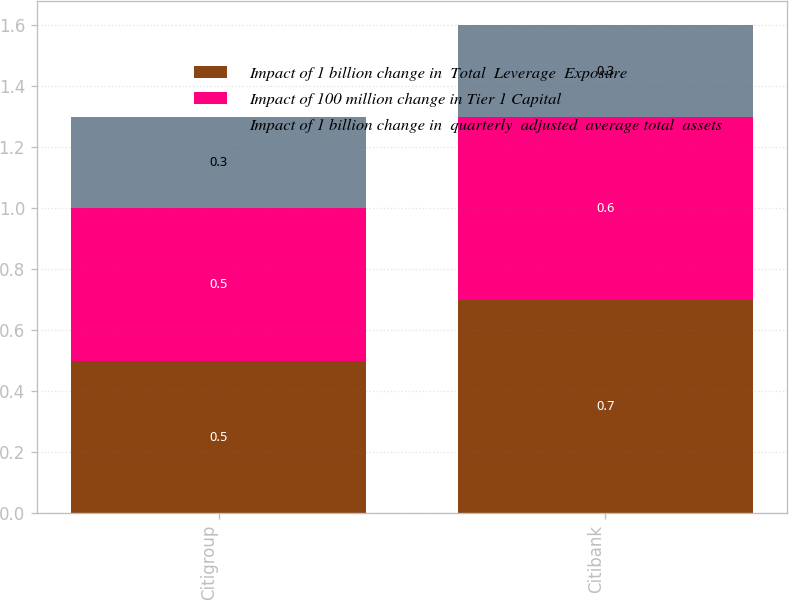Convert chart. <chart><loc_0><loc_0><loc_500><loc_500><stacked_bar_chart><ecel><fcel>Citigroup<fcel>Citibank<nl><fcel>Impact of 1 billion change in  Total  Leverage  Exposure<fcel>0.5<fcel>0.7<nl><fcel>Impact of 100 million change in Tier 1 Capital<fcel>0.5<fcel>0.6<nl><fcel>Impact of 1 billion change in  quarterly  adjusted  average total  assets<fcel>0.3<fcel>0.3<nl></chart> 